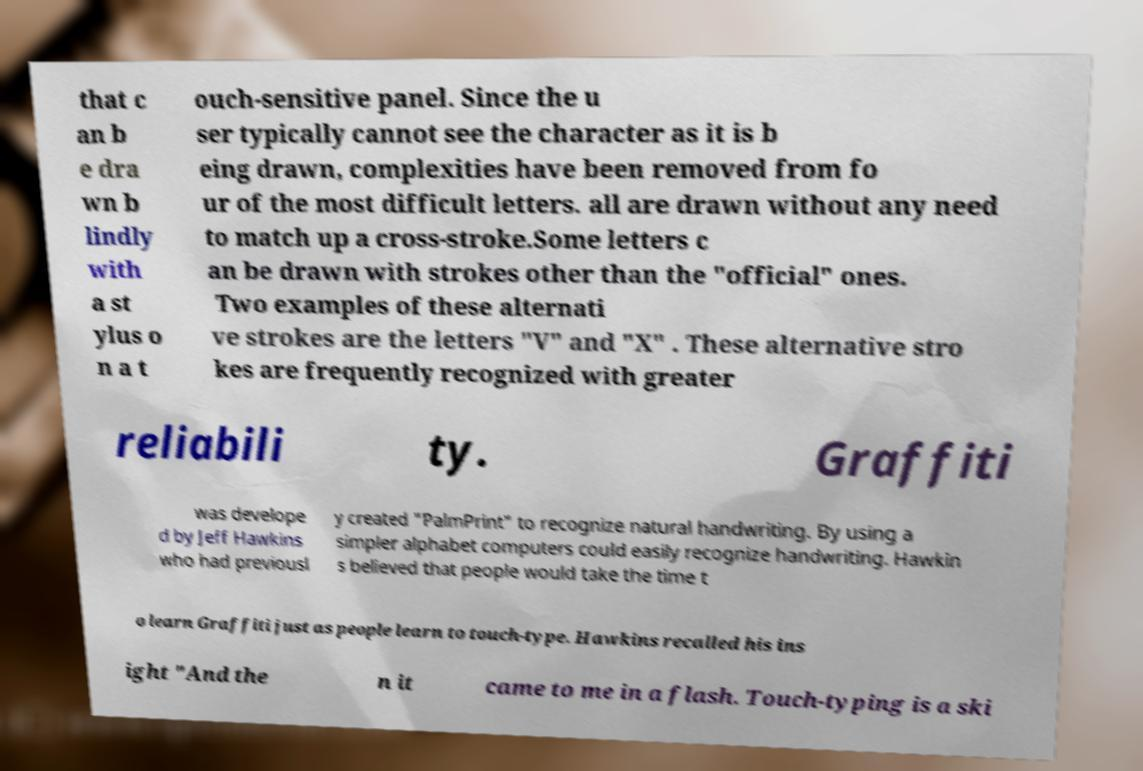What messages or text are displayed in this image? I need them in a readable, typed format. that c an b e dra wn b lindly with a st ylus o n a t ouch-sensitive panel. Since the u ser typically cannot see the character as it is b eing drawn, complexities have been removed from fo ur of the most difficult letters. all are drawn without any need to match up a cross-stroke.Some letters c an be drawn with strokes other than the "official" ones. Two examples of these alternati ve strokes are the letters "V" and "X" . These alternative stro kes are frequently recognized with greater reliabili ty. Graffiti was develope d by Jeff Hawkins who had previousl y created "PalmPrint" to recognize natural handwriting. By using a simpler alphabet computers could easily recognize handwriting. Hawkin s believed that people would take the time t o learn Graffiti just as people learn to touch-type. Hawkins recalled his ins ight "And the n it came to me in a flash. Touch-typing is a ski 